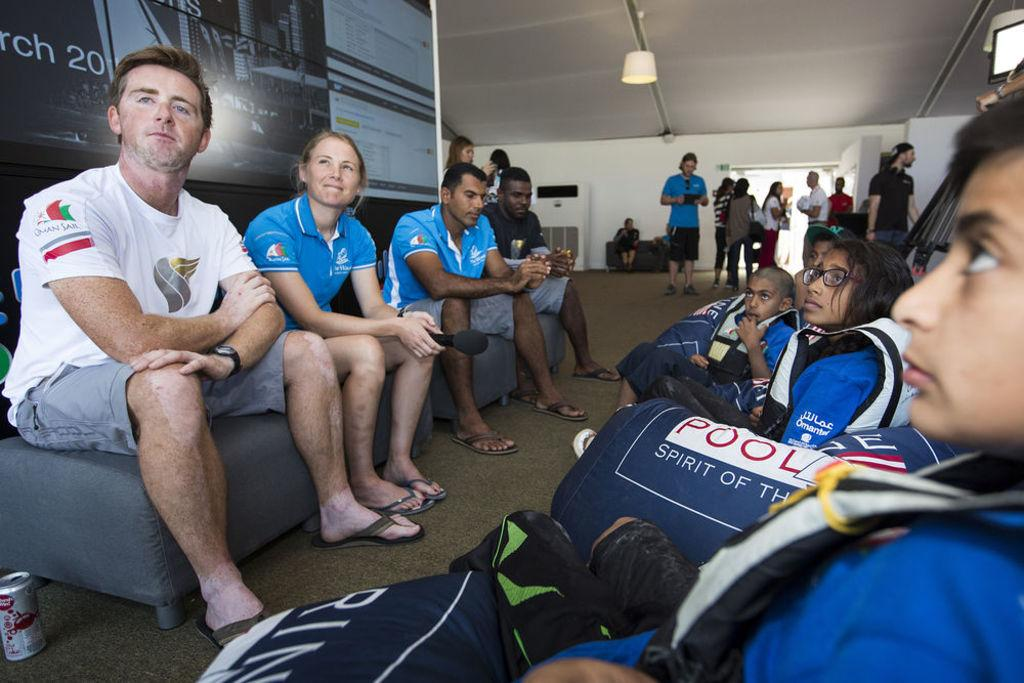<image>
Summarize the visual content of the image. a few people sitting with the number 20 behind them on a sign 